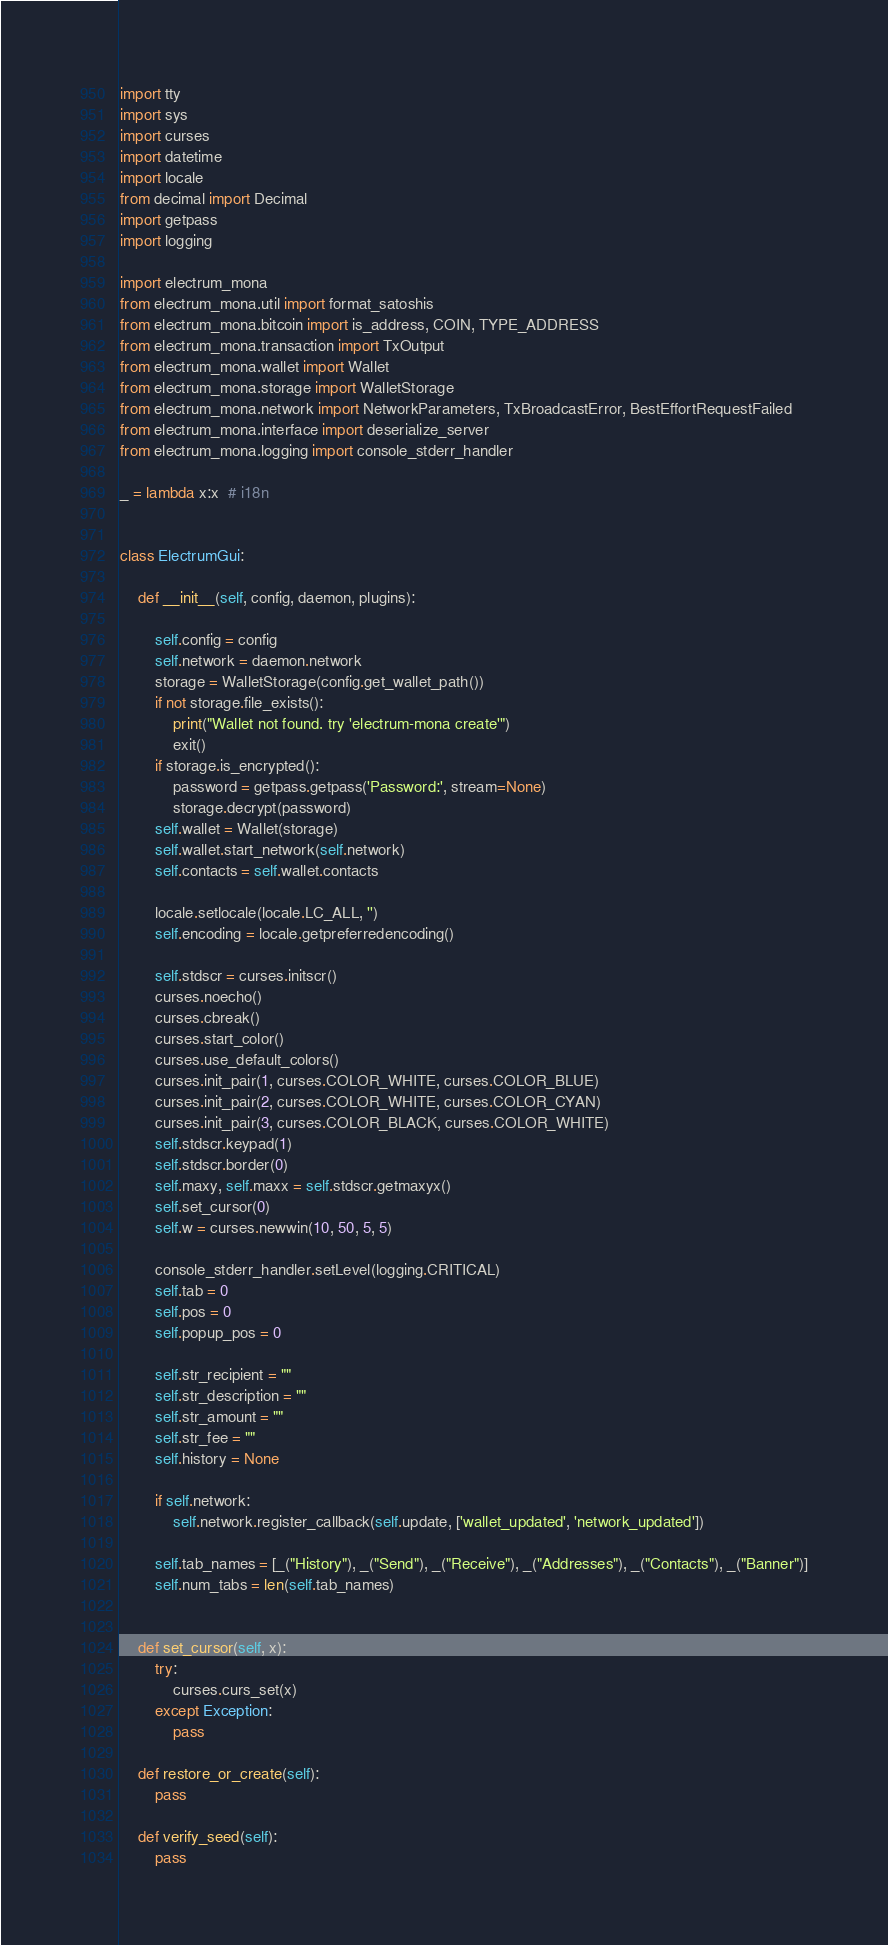Convert code to text. <code><loc_0><loc_0><loc_500><loc_500><_Python_>import tty
import sys
import curses
import datetime
import locale
from decimal import Decimal
import getpass
import logging

import electrum_mona
from electrum_mona.util import format_satoshis
from electrum_mona.bitcoin import is_address, COIN, TYPE_ADDRESS
from electrum_mona.transaction import TxOutput
from electrum_mona.wallet import Wallet
from electrum_mona.storage import WalletStorage
from electrum_mona.network import NetworkParameters, TxBroadcastError, BestEffortRequestFailed
from electrum_mona.interface import deserialize_server
from electrum_mona.logging import console_stderr_handler

_ = lambda x:x  # i18n


class ElectrumGui:

    def __init__(self, config, daemon, plugins):

        self.config = config
        self.network = daemon.network
        storage = WalletStorage(config.get_wallet_path())
        if not storage.file_exists():
            print("Wallet not found. try 'electrum-mona create'")
            exit()
        if storage.is_encrypted():
            password = getpass.getpass('Password:', stream=None)
            storage.decrypt(password)
        self.wallet = Wallet(storage)
        self.wallet.start_network(self.network)
        self.contacts = self.wallet.contacts

        locale.setlocale(locale.LC_ALL, '')
        self.encoding = locale.getpreferredencoding()

        self.stdscr = curses.initscr()
        curses.noecho()
        curses.cbreak()
        curses.start_color()
        curses.use_default_colors()
        curses.init_pair(1, curses.COLOR_WHITE, curses.COLOR_BLUE)
        curses.init_pair(2, curses.COLOR_WHITE, curses.COLOR_CYAN)
        curses.init_pair(3, curses.COLOR_BLACK, curses.COLOR_WHITE)
        self.stdscr.keypad(1)
        self.stdscr.border(0)
        self.maxy, self.maxx = self.stdscr.getmaxyx()
        self.set_cursor(0)
        self.w = curses.newwin(10, 50, 5, 5)

        console_stderr_handler.setLevel(logging.CRITICAL)
        self.tab = 0
        self.pos = 0
        self.popup_pos = 0

        self.str_recipient = ""
        self.str_description = ""
        self.str_amount = ""
        self.str_fee = ""
        self.history = None

        if self.network:
            self.network.register_callback(self.update, ['wallet_updated', 'network_updated'])

        self.tab_names = [_("History"), _("Send"), _("Receive"), _("Addresses"), _("Contacts"), _("Banner")]
        self.num_tabs = len(self.tab_names)


    def set_cursor(self, x):
        try:
            curses.curs_set(x)
        except Exception:
            pass

    def restore_or_create(self):
        pass

    def verify_seed(self):
        pass
</code> 